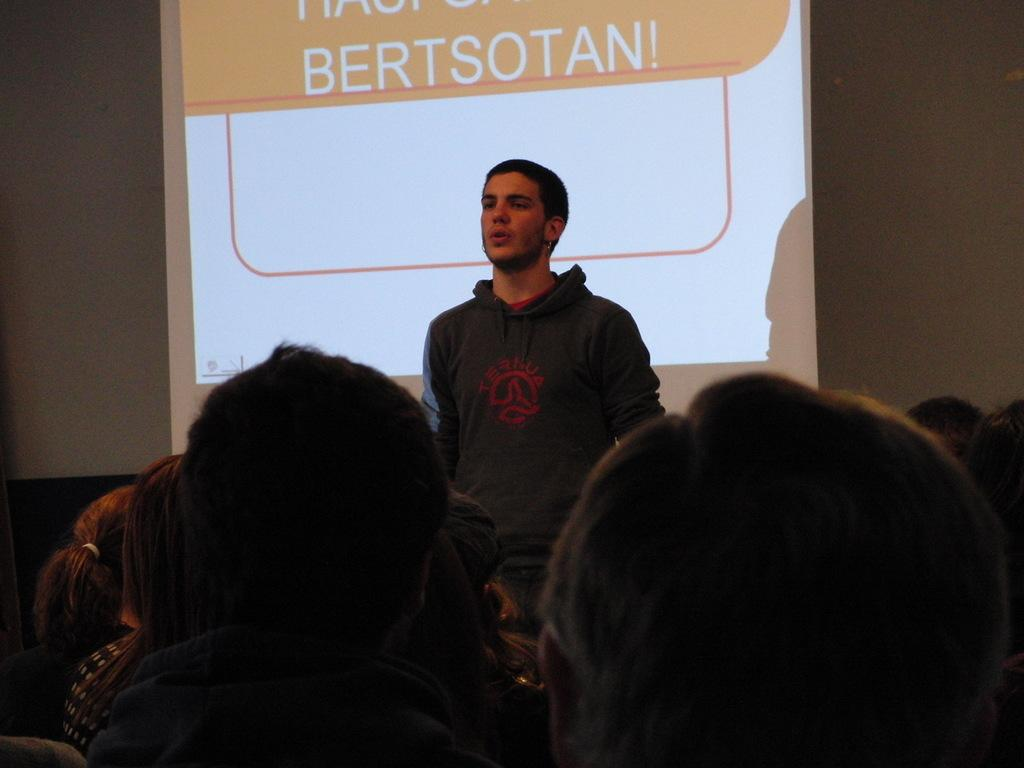What is the main subject in the center of the image? There is a man standing in the center of the image. What are the people at the bottom of the image doing? The people sitting at the bottom of the image are not engaged in any specific activity. What can be seen in the background of the image? There is a screen and a wall in the background of the image. What type of pin is being used to hold the man's clothes together in the image? There is no pin visible in the image, and the man's clothes do not appear to be held together by any pin. 